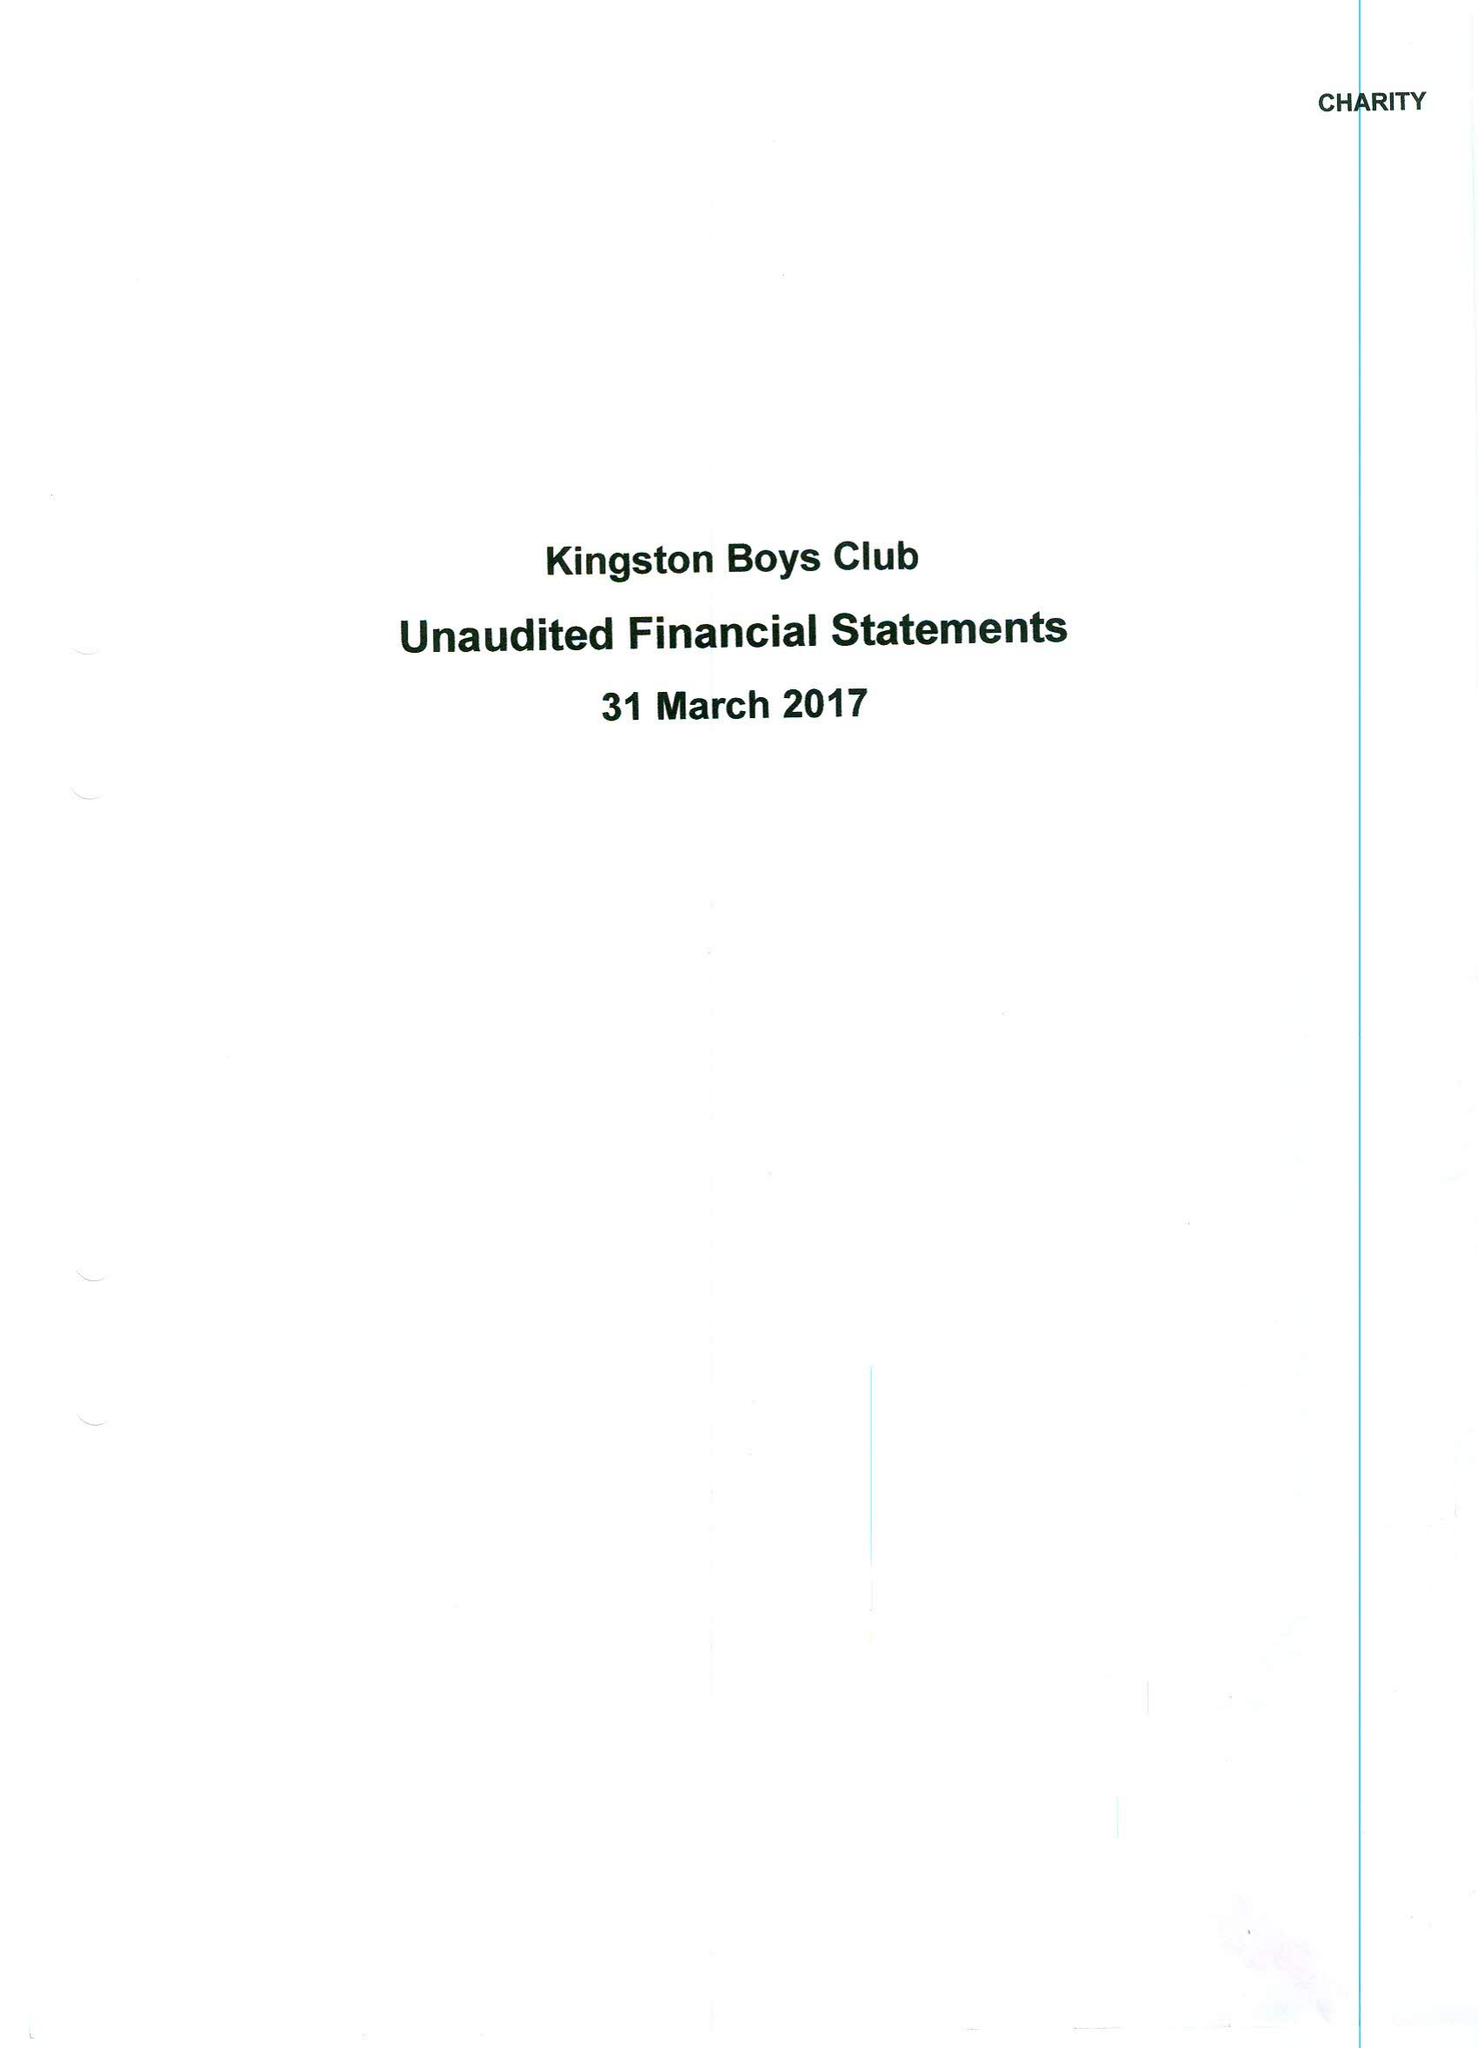What is the value for the income_annually_in_british_pounds?
Answer the question using a single word or phrase. 28783.00 